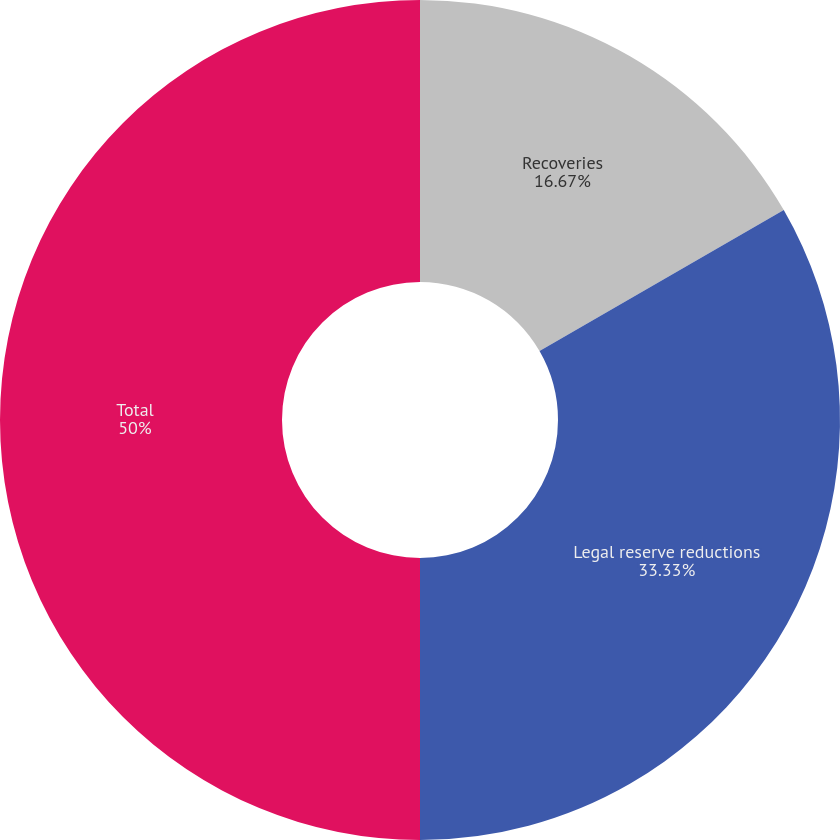<chart> <loc_0><loc_0><loc_500><loc_500><pie_chart><fcel>Recoveries<fcel>Legal reserve reductions<fcel>Total<nl><fcel>16.67%<fcel>33.33%<fcel>50.0%<nl></chart> 